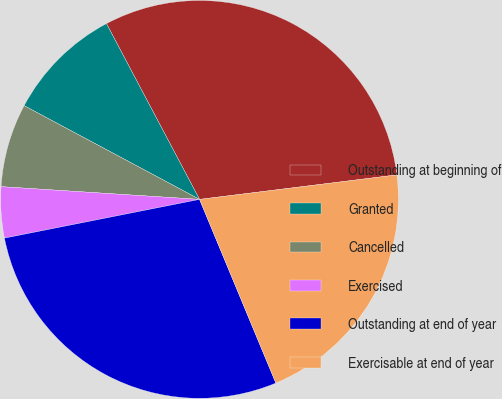Convert chart. <chart><loc_0><loc_0><loc_500><loc_500><pie_chart><fcel>Outstanding at beginning of<fcel>Granted<fcel>Cancelled<fcel>Exercised<fcel>Outstanding at end of year<fcel>Exercisable at end of year<nl><fcel>30.79%<fcel>9.44%<fcel>6.79%<fcel>4.14%<fcel>28.15%<fcel>20.7%<nl></chart> 